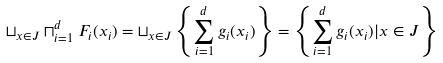<formula> <loc_0><loc_0><loc_500><loc_500>\sqcup _ { x \in J } \sqcap _ { i = 1 } ^ { d } F _ { i } ( x _ { i } ) & = \sqcup _ { x \in J } \left \{ \sum _ { i = 1 } ^ { d } g _ { i } ( x _ { i } ) \right \} = \left \{ \sum _ { i = 1 } ^ { d } g _ { i } ( x _ { i } ) | x \in J \right \}</formula> 